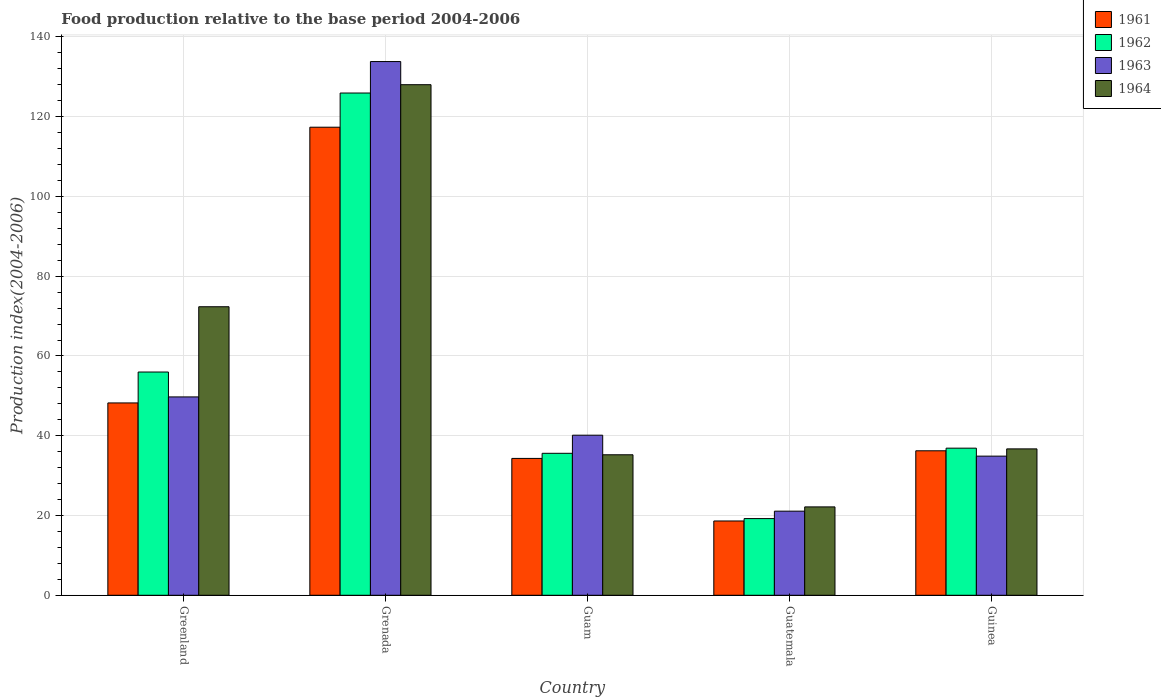How many groups of bars are there?
Your answer should be very brief. 5. How many bars are there on the 4th tick from the right?
Give a very brief answer. 4. What is the label of the 1st group of bars from the left?
Your answer should be compact. Greenland. What is the food production index in 1961 in Guam?
Make the answer very short. 34.32. Across all countries, what is the maximum food production index in 1962?
Make the answer very short. 125.94. Across all countries, what is the minimum food production index in 1962?
Offer a very short reply. 19.23. In which country was the food production index in 1963 maximum?
Provide a short and direct response. Grenada. In which country was the food production index in 1962 minimum?
Ensure brevity in your answer.  Guatemala. What is the total food production index in 1963 in the graph?
Give a very brief answer. 279.69. What is the difference between the food production index in 1963 in Greenland and that in Guatemala?
Provide a short and direct response. 28.65. What is the difference between the food production index in 1964 in Guatemala and the food production index in 1963 in Guinea?
Keep it short and to the point. -12.73. What is the average food production index in 1963 per country?
Offer a very short reply. 55.94. What is the difference between the food production index of/in 1961 and food production index of/in 1962 in Grenada?
Provide a succinct answer. -8.57. What is the ratio of the food production index in 1961 in Grenada to that in Guam?
Your answer should be compact. 3.42. Is the difference between the food production index in 1961 in Greenland and Guatemala greater than the difference between the food production index in 1962 in Greenland and Guatemala?
Offer a very short reply. No. What is the difference between the highest and the second highest food production index in 1963?
Your answer should be very brief. -9.6. What is the difference between the highest and the lowest food production index in 1962?
Ensure brevity in your answer.  106.71. In how many countries, is the food production index in 1961 greater than the average food production index in 1961 taken over all countries?
Ensure brevity in your answer.  1. Is the sum of the food production index in 1961 in Greenland and Grenada greater than the maximum food production index in 1964 across all countries?
Give a very brief answer. Yes. What does the 2nd bar from the left in Guinea represents?
Provide a succinct answer. 1962. What does the 4th bar from the right in Guam represents?
Your answer should be very brief. 1961. Is it the case that in every country, the sum of the food production index in 1961 and food production index in 1964 is greater than the food production index in 1962?
Your response must be concise. Yes. How many bars are there?
Your answer should be very brief. 20. How many countries are there in the graph?
Offer a very short reply. 5. Are the values on the major ticks of Y-axis written in scientific E-notation?
Offer a terse response. No. What is the title of the graph?
Give a very brief answer. Food production relative to the base period 2004-2006. What is the label or title of the X-axis?
Ensure brevity in your answer.  Country. What is the label or title of the Y-axis?
Your answer should be very brief. Production index(2004-2006). What is the Production index(2004-2006) in 1961 in Greenland?
Make the answer very short. 48.23. What is the Production index(2004-2006) in 1962 in Greenland?
Offer a very short reply. 55.98. What is the Production index(2004-2006) in 1963 in Greenland?
Your answer should be compact. 49.74. What is the Production index(2004-2006) in 1964 in Greenland?
Offer a terse response. 72.35. What is the Production index(2004-2006) in 1961 in Grenada?
Keep it short and to the point. 117.37. What is the Production index(2004-2006) in 1962 in Grenada?
Provide a succinct answer. 125.94. What is the Production index(2004-2006) in 1963 in Grenada?
Make the answer very short. 133.83. What is the Production index(2004-2006) of 1964 in Grenada?
Your answer should be compact. 128.03. What is the Production index(2004-2006) in 1961 in Guam?
Offer a very short reply. 34.32. What is the Production index(2004-2006) of 1962 in Guam?
Your answer should be very brief. 35.6. What is the Production index(2004-2006) in 1963 in Guam?
Make the answer very short. 40.14. What is the Production index(2004-2006) in 1964 in Guam?
Provide a succinct answer. 35.23. What is the Production index(2004-2006) in 1961 in Guatemala?
Provide a short and direct response. 18.63. What is the Production index(2004-2006) of 1962 in Guatemala?
Offer a terse response. 19.23. What is the Production index(2004-2006) in 1963 in Guatemala?
Give a very brief answer. 21.09. What is the Production index(2004-2006) of 1964 in Guatemala?
Your answer should be compact. 22.16. What is the Production index(2004-2006) of 1961 in Guinea?
Offer a very short reply. 36.23. What is the Production index(2004-2006) in 1962 in Guinea?
Give a very brief answer. 36.89. What is the Production index(2004-2006) of 1963 in Guinea?
Your answer should be very brief. 34.89. What is the Production index(2004-2006) of 1964 in Guinea?
Give a very brief answer. 36.71. Across all countries, what is the maximum Production index(2004-2006) of 1961?
Keep it short and to the point. 117.37. Across all countries, what is the maximum Production index(2004-2006) in 1962?
Keep it short and to the point. 125.94. Across all countries, what is the maximum Production index(2004-2006) in 1963?
Make the answer very short. 133.83. Across all countries, what is the maximum Production index(2004-2006) in 1964?
Ensure brevity in your answer.  128.03. Across all countries, what is the minimum Production index(2004-2006) in 1961?
Offer a very short reply. 18.63. Across all countries, what is the minimum Production index(2004-2006) in 1962?
Keep it short and to the point. 19.23. Across all countries, what is the minimum Production index(2004-2006) of 1963?
Provide a short and direct response. 21.09. Across all countries, what is the minimum Production index(2004-2006) of 1964?
Your response must be concise. 22.16. What is the total Production index(2004-2006) of 1961 in the graph?
Provide a short and direct response. 254.78. What is the total Production index(2004-2006) in 1962 in the graph?
Your answer should be very brief. 273.64. What is the total Production index(2004-2006) in 1963 in the graph?
Provide a short and direct response. 279.69. What is the total Production index(2004-2006) of 1964 in the graph?
Your answer should be very brief. 294.48. What is the difference between the Production index(2004-2006) of 1961 in Greenland and that in Grenada?
Give a very brief answer. -69.14. What is the difference between the Production index(2004-2006) of 1962 in Greenland and that in Grenada?
Provide a short and direct response. -69.96. What is the difference between the Production index(2004-2006) of 1963 in Greenland and that in Grenada?
Provide a short and direct response. -84.09. What is the difference between the Production index(2004-2006) of 1964 in Greenland and that in Grenada?
Your response must be concise. -55.68. What is the difference between the Production index(2004-2006) in 1961 in Greenland and that in Guam?
Offer a very short reply. 13.91. What is the difference between the Production index(2004-2006) in 1962 in Greenland and that in Guam?
Offer a terse response. 20.38. What is the difference between the Production index(2004-2006) of 1963 in Greenland and that in Guam?
Make the answer very short. 9.6. What is the difference between the Production index(2004-2006) in 1964 in Greenland and that in Guam?
Your answer should be compact. 37.12. What is the difference between the Production index(2004-2006) in 1961 in Greenland and that in Guatemala?
Make the answer very short. 29.6. What is the difference between the Production index(2004-2006) in 1962 in Greenland and that in Guatemala?
Provide a short and direct response. 36.75. What is the difference between the Production index(2004-2006) in 1963 in Greenland and that in Guatemala?
Provide a short and direct response. 28.65. What is the difference between the Production index(2004-2006) in 1964 in Greenland and that in Guatemala?
Offer a very short reply. 50.19. What is the difference between the Production index(2004-2006) in 1961 in Greenland and that in Guinea?
Offer a terse response. 12. What is the difference between the Production index(2004-2006) in 1962 in Greenland and that in Guinea?
Provide a succinct answer. 19.09. What is the difference between the Production index(2004-2006) in 1963 in Greenland and that in Guinea?
Provide a short and direct response. 14.85. What is the difference between the Production index(2004-2006) of 1964 in Greenland and that in Guinea?
Keep it short and to the point. 35.64. What is the difference between the Production index(2004-2006) of 1961 in Grenada and that in Guam?
Your answer should be compact. 83.05. What is the difference between the Production index(2004-2006) of 1962 in Grenada and that in Guam?
Offer a terse response. 90.34. What is the difference between the Production index(2004-2006) of 1963 in Grenada and that in Guam?
Your answer should be very brief. 93.69. What is the difference between the Production index(2004-2006) in 1964 in Grenada and that in Guam?
Make the answer very short. 92.8. What is the difference between the Production index(2004-2006) in 1961 in Grenada and that in Guatemala?
Offer a terse response. 98.74. What is the difference between the Production index(2004-2006) of 1962 in Grenada and that in Guatemala?
Keep it short and to the point. 106.71. What is the difference between the Production index(2004-2006) in 1963 in Grenada and that in Guatemala?
Offer a terse response. 112.74. What is the difference between the Production index(2004-2006) in 1964 in Grenada and that in Guatemala?
Offer a terse response. 105.87. What is the difference between the Production index(2004-2006) of 1961 in Grenada and that in Guinea?
Offer a terse response. 81.14. What is the difference between the Production index(2004-2006) of 1962 in Grenada and that in Guinea?
Your answer should be very brief. 89.05. What is the difference between the Production index(2004-2006) of 1963 in Grenada and that in Guinea?
Offer a very short reply. 98.94. What is the difference between the Production index(2004-2006) of 1964 in Grenada and that in Guinea?
Your answer should be compact. 91.32. What is the difference between the Production index(2004-2006) of 1961 in Guam and that in Guatemala?
Offer a very short reply. 15.69. What is the difference between the Production index(2004-2006) in 1962 in Guam and that in Guatemala?
Provide a short and direct response. 16.37. What is the difference between the Production index(2004-2006) in 1963 in Guam and that in Guatemala?
Your answer should be compact. 19.05. What is the difference between the Production index(2004-2006) of 1964 in Guam and that in Guatemala?
Your answer should be compact. 13.07. What is the difference between the Production index(2004-2006) in 1961 in Guam and that in Guinea?
Your answer should be compact. -1.91. What is the difference between the Production index(2004-2006) in 1962 in Guam and that in Guinea?
Give a very brief answer. -1.29. What is the difference between the Production index(2004-2006) of 1963 in Guam and that in Guinea?
Your answer should be compact. 5.25. What is the difference between the Production index(2004-2006) of 1964 in Guam and that in Guinea?
Make the answer very short. -1.48. What is the difference between the Production index(2004-2006) of 1961 in Guatemala and that in Guinea?
Offer a terse response. -17.6. What is the difference between the Production index(2004-2006) of 1962 in Guatemala and that in Guinea?
Offer a very short reply. -17.66. What is the difference between the Production index(2004-2006) of 1964 in Guatemala and that in Guinea?
Provide a succinct answer. -14.55. What is the difference between the Production index(2004-2006) of 1961 in Greenland and the Production index(2004-2006) of 1962 in Grenada?
Give a very brief answer. -77.71. What is the difference between the Production index(2004-2006) of 1961 in Greenland and the Production index(2004-2006) of 1963 in Grenada?
Ensure brevity in your answer.  -85.6. What is the difference between the Production index(2004-2006) of 1961 in Greenland and the Production index(2004-2006) of 1964 in Grenada?
Your response must be concise. -79.8. What is the difference between the Production index(2004-2006) in 1962 in Greenland and the Production index(2004-2006) in 1963 in Grenada?
Offer a terse response. -77.85. What is the difference between the Production index(2004-2006) in 1962 in Greenland and the Production index(2004-2006) in 1964 in Grenada?
Keep it short and to the point. -72.05. What is the difference between the Production index(2004-2006) of 1963 in Greenland and the Production index(2004-2006) of 1964 in Grenada?
Give a very brief answer. -78.29. What is the difference between the Production index(2004-2006) of 1961 in Greenland and the Production index(2004-2006) of 1962 in Guam?
Offer a terse response. 12.63. What is the difference between the Production index(2004-2006) in 1961 in Greenland and the Production index(2004-2006) in 1963 in Guam?
Offer a terse response. 8.09. What is the difference between the Production index(2004-2006) of 1961 in Greenland and the Production index(2004-2006) of 1964 in Guam?
Your answer should be very brief. 13. What is the difference between the Production index(2004-2006) in 1962 in Greenland and the Production index(2004-2006) in 1963 in Guam?
Offer a very short reply. 15.84. What is the difference between the Production index(2004-2006) in 1962 in Greenland and the Production index(2004-2006) in 1964 in Guam?
Your answer should be compact. 20.75. What is the difference between the Production index(2004-2006) in 1963 in Greenland and the Production index(2004-2006) in 1964 in Guam?
Offer a very short reply. 14.51. What is the difference between the Production index(2004-2006) of 1961 in Greenland and the Production index(2004-2006) of 1963 in Guatemala?
Keep it short and to the point. 27.14. What is the difference between the Production index(2004-2006) of 1961 in Greenland and the Production index(2004-2006) of 1964 in Guatemala?
Ensure brevity in your answer.  26.07. What is the difference between the Production index(2004-2006) of 1962 in Greenland and the Production index(2004-2006) of 1963 in Guatemala?
Offer a very short reply. 34.89. What is the difference between the Production index(2004-2006) of 1962 in Greenland and the Production index(2004-2006) of 1964 in Guatemala?
Your answer should be very brief. 33.82. What is the difference between the Production index(2004-2006) of 1963 in Greenland and the Production index(2004-2006) of 1964 in Guatemala?
Ensure brevity in your answer.  27.58. What is the difference between the Production index(2004-2006) of 1961 in Greenland and the Production index(2004-2006) of 1962 in Guinea?
Give a very brief answer. 11.34. What is the difference between the Production index(2004-2006) of 1961 in Greenland and the Production index(2004-2006) of 1963 in Guinea?
Ensure brevity in your answer.  13.34. What is the difference between the Production index(2004-2006) of 1961 in Greenland and the Production index(2004-2006) of 1964 in Guinea?
Offer a terse response. 11.52. What is the difference between the Production index(2004-2006) of 1962 in Greenland and the Production index(2004-2006) of 1963 in Guinea?
Keep it short and to the point. 21.09. What is the difference between the Production index(2004-2006) in 1962 in Greenland and the Production index(2004-2006) in 1964 in Guinea?
Keep it short and to the point. 19.27. What is the difference between the Production index(2004-2006) in 1963 in Greenland and the Production index(2004-2006) in 1964 in Guinea?
Offer a very short reply. 13.03. What is the difference between the Production index(2004-2006) in 1961 in Grenada and the Production index(2004-2006) in 1962 in Guam?
Your answer should be compact. 81.77. What is the difference between the Production index(2004-2006) of 1961 in Grenada and the Production index(2004-2006) of 1963 in Guam?
Keep it short and to the point. 77.23. What is the difference between the Production index(2004-2006) of 1961 in Grenada and the Production index(2004-2006) of 1964 in Guam?
Provide a succinct answer. 82.14. What is the difference between the Production index(2004-2006) in 1962 in Grenada and the Production index(2004-2006) in 1963 in Guam?
Keep it short and to the point. 85.8. What is the difference between the Production index(2004-2006) of 1962 in Grenada and the Production index(2004-2006) of 1964 in Guam?
Provide a succinct answer. 90.71. What is the difference between the Production index(2004-2006) in 1963 in Grenada and the Production index(2004-2006) in 1964 in Guam?
Your response must be concise. 98.6. What is the difference between the Production index(2004-2006) in 1961 in Grenada and the Production index(2004-2006) in 1962 in Guatemala?
Make the answer very short. 98.14. What is the difference between the Production index(2004-2006) of 1961 in Grenada and the Production index(2004-2006) of 1963 in Guatemala?
Offer a terse response. 96.28. What is the difference between the Production index(2004-2006) in 1961 in Grenada and the Production index(2004-2006) in 1964 in Guatemala?
Give a very brief answer. 95.21. What is the difference between the Production index(2004-2006) of 1962 in Grenada and the Production index(2004-2006) of 1963 in Guatemala?
Provide a short and direct response. 104.85. What is the difference between the Production index(2004-2006) in 1962 in Grenada and the Production index(2004-2006) in 1964 in Guatemala?
Ensure brevity in your answer.  103.78. What is the difference between the Production index(2004-2006) in 1963 in Grenada and the Production index(2004-2006) in 1964 in Guatemala?
Keep it short and to the point. 111.67. What is the difference between the Production index(2004-2006) of 1961 in Grenada and the Production index(2004-2006) of 1962 in Guinea?
Provide a short and direct response. 80.48. What is the difference between the Production index(2004-2006) in 1961 in Grenada and the Production index(2004-2006) in 1963 in Guinea?
Offer a very short reply. 82.48. What is the difference between the Production index(2004-2006) in 1961 in Grenada and the Production index(2004-2006) in 1964 in Guinea?
Make the answer very short. 80.66. What is the difference between the Production index(2004-2006) of 1962 in Grenada and the Production index(2004-2006) of 1963 in Guinea?
Give a very brief answer. 91.05. What is the difference between the Production index(2004-2006) in 1962 in Grenada and the Production index(2004-2006) in 1964 in Guinea?
Your response must be concise. 89.23. What is the difference between the Production index(2004-2006) of 1963 in Grenada and the Production index(2004-2006) of 1964 in Guinea?
Your response must be concise. 97.12. What is the difference between the Production index(2004-2006) in 1961 in Guam and the Production index(2004-2006) in 1962 in Guatemala?
Provide a succinct answer. 15.09. What is the difference between the Production index(2004-2006) in 1961 in Guam and the Production index(2004-2006) in 1963 in Guatemala?
Keep it short and to the point. 13.23. What is the difference between the Production index(2004-2006) of 1961 in Guam and the Production index(2004-2006) of 1964 in Guatemala?
Provide a short and direct response. 12.16. What is the difference between the Production index(2004-2006) of 1962 in Guam and the Production index(2004-2006) of 1963 in Guatemala?
Offer a very short reply. 14.51. What is the difference between the Production index(2004-2006) in 1962 in Guam and the Production index(2004-2006) in 1964 in Guatemala?
Keep it short and to the point. 13.44. What is the difference between the Production index(2004-2006) in 1963 in Guam and the Production index(2004-2006) in 1964 in Guatemala?
Offer a terse response. 17.98. What is the difference between the Production index(2004-2006) of 1961 in Guam and the Production index(2004-2006) of 1962 in Guinea?
Provide a short and direct response. -2.57. What is the difference between the Production index(2004-2006) in 1961 in Guam and the Production index(2004-2006) in 1963 in Guinea?
Your response must be concise. -0.57. What is the difference between the Production index(2004-2006) of 1961 in Guam and the Production index(2004-2006) of 1964 in Guinea?
Offer a terse response. -2.39. What is the difference between the Production index(2004-2006) of 1962 in Guam and the Production index(2004-2006) of 1963 in Guinea?
Make the answer very short. 0.71. What is the difference between the Production index(2004-2006) in 1962 in Guam and the Production index(2004-2006) in 1964 in Guinea?
Keep it short and to the point. -1.11. What is the difference between the Production index(2004-2006) of 1963 in Guam and the Production index(2004-2006) of 1964 in Guinea?
Give a very brief answer. 3.43. What is the difference between the Production index(2004-2006) in 1961 in Guatemala and the Production index(2004-2006) in 1962 in Guinea?
Ensure brevity in your answer.  -18.26. What is the difference between the Production index(2004-2006) of 1961 in Guatemala and the Production index(2004-2006) of 1963 in Guinea?
Provide a short and direct response. -16.26. What is the difference between the Production index(2004-2006) of 1961 in Guatemala and the Production index(2004-2006) of 1964 in Guinea?
Provide a short and direct response. -18.08. What is the difference between the Production index(2004-2006) of 1962 in Guatemala and the Production index(2004-2006) of 1963 in Guinea?
Make the answer very short. -15.66. What is the difference between the Production index(2004-2006) of 1962 in Guatemala and the Production index(2004-2006) of 1964 in Guinea?
Keep it short and to the point. -17.48. What is the difference between the Production index(2004-2006) of 1963 in Guatemala and the Production index(2004-2006) of 1964 in Guinea?
Provide a succinct answer. -15.62. What is the average Production index(2004-2006) of 1961 per country?
Ensure brevity in your answer.  50.96. What is the average Production index(2004-2006) in 1962 per country?
Your answer should be compact. 54.73. What is the average Production index(2004-2006) in 1963 per country?
Your response must be concise. 55.94. What is the average Production index(2004-2006) of 1964 per country?
Make the answer very short. 58.9. What is the difference between the Production index(2004-2006) of 1961 and Production index(2004-2006) of 1962 in Greenland?
Your answer should be compact. -7.75. What is the difference between the Production index(2004-2006) of 1961 and Production index(2004-2006) of 1963 in Greenland?
Provide a short and direct response. -1.51. What is the difference between the Production index(2004-2006) of 1961 and Production index(2004-2006) of 1964 in Greenland?
Your answer should be compact. -24.12. What is the difference between the Production index(2004-2006) of 1962 and Production index(2004-2006) of 1963 in Greenland?
Give a very brief answer. 6.24. What is the difference between the Production index(2004-2006) of 1962 and Production index(2004-2006) of 1964 in Greenland?
Ensure brevity in your answer.  -16.37. What is the difference between the Production index(2004-2006) of 1963 and Production index(2004-2006) of 1964 in Greenland?
Offer a very short reply. -22.61. What is the difference between the Production index(2004-2006) of 1961 and Production index(2004-2006) of 1962 in Grenada?
Provide a succinct answer. -8.57. What is the difference between the Production index(2004-2006) in 1961 and Production index(2004-2006) in 1963 in Grenada?
Make the answer very short. -16.46. What is the difference between the Production index(2004-2006) in 1961 and Production index(2004-2006) in 1964 in Grenada?
Provide a succinct answer. -10.66. What is the difference between the Production index(2004-2006) in 1962 and Production index(2004-2006) in 1963 in Grenada?
Your answer should be compact. -7.89. What is the difference between the Production index(2004-2006) of 1962 and Production index(2004-2006) of 1964 in Grenada?
Keep it short and to the point. -2.09. What is the difference between the Production index(2004-2006) of 1961 and Production index(2004-2006) of 1962 in Guam?
Your answer should be compact. -1.28. What is the difference between the Production index(2004-2006) in 1961 and Production index(2004-2006) in 1963 in Guam?
Offer a terse response. -5.82. What is the difference between the Production index(2004-2006) of 1961 and Production index(2004-2006) of 1964 in Guam?
Your answer should be compact. -0.91. What is the difference between the Production index(2004-2006) in 1962 and Production index(2004-2006) in 1963 in Guam?
Offer a terse response. -4.54. What is the difference between the Production index(2004-2006) in 1962 and Production index(2004-2006) in 1964 in Guam?
Offer a very short reply. 0.37. What is the difference between the Production index(2004-2006) of 1963 and Production index(2004-2006) of 1964 in Guam?
Your answer should be compact. 4.91. What is the difference between the Production index(2004-2006) of 1961 and Production index(2004-2006) of 1962 in Guatemala?
Keep it short and to the point. -0.6. What is the difference between the Production index(2004-2006) in 1961 and Production index(2004-2006) in 1963 in Guatemala?
Provide a short and direct response. -2.46. What is the difference between the Production index(2004-2006) in 1961 and Production index(2004-2006) in 1964 in Guatemala?
Give a very brief answer. -3.53. What is the difference between the Production index(2004-2006) in 1962 and Production index(2004-2006) in 1963 in Guatemala?
Provide a short and direct response. -1.86. What is the difference between the Production index(2004-2006) in 1962 and Production index(2004-2006) in 1964 in Guatemala?
Provide a short and direct response. -2.93. What is the difference between the Production index(2004-2006) in 1963 and Production index(2004-2006) in 1964 in Guatemala?
Provide a short and direct response. -1.07. What is the difference between the Production index(2004-2006) in 1961 and Production index(2004-2006) in 1962 in Guinea?
Offer a terse response. -0.66. What is the difference between the Production index(2004-2006) in 1961 and Production index(2004-2006) in 1963 in Guinea?
Provide a succinct answer. 1.34. What is the difference between the Production index(2004-2006) of 1961 and Production index(2004-2006) of 1964 in Guinea?
Offer a terse response. -0.48. What is the difference between the Production index(2004-2006) in 1962 and Production index(2004-2006) in 1963 in Guinea?
Keep it short and to the point. 2. What is the difference between the Production index(2004-2006) of 1962 and Production index(2004-2006) of 1964 in Guinea?
Your answer should be compact. 0.18. What is the difference between the Production index(2004-2006) in 1963 and Production index(2004-2006) in 1964 in Guinea?
Provide a short and direct response. -1.82. What is the ratio of the Production index(2004-2006) in 1961 in Greenland to that in Grenada?
Provide a succinct answer. 0.41. What is the ratio of the Production index(2004-2006) in 1962 in Greenland to that in Grenada?
Ensure brevity in your answer.  0.44. What is the ratio of the Production index(2004-2006) in 1963 in Greenland to that in Grenada?
Keep it short and to the point. 0.37. What is the ratio of the Production index(2004-2006) of 1964 in Greenland to that in Grenada?
Give a very brief answer. 0.57. What is the ratio of the Production index(2004-2006) in 1961 in Greenland to that in Guam?
Offer a terse response. 1.41. What is the ratio of the Production index(2004-2006) of 1962 in Greenland to that in Guam?
Your answer should be very brief. 1.57. What is the ratio of the Production index(2004-2006) of 1963 in Greenland to that in Guam?
Provide a succinct answer. 1.24. What is the ratio of the Production index(2004-2006) of 1964 in Greenland to that in Guam?
Your answer should be very brief. 2.05. What is the ratio of the Production index(2004-2006) in 1961 in Greenland to that in Guatemala?
Provide a short and direct response. 2.59. What is the ratio of the Production index(2004-2006) in 1962 in Greenland to that in Guatemala?
Provide a short and direct response. 2.91. What is the ratio of the Production index(2004-2006) in 1963 in Greenland to that in Guatemala?
Keep it short and to the point. 2.36. What is the ratio of the Production index(2004-2006) of 1964 in Greenland to that in Guatemala?
Give a very brief answer. 3.26. What is the ratio of the Production index(2004-2006) of 1961 in Greenland to that in Guinea?
Your response must be concise. 1.33. What is the ratio of the Production index(2004-2006) of 1962 in Greenland to that in Guinea?
Your response must be concise. 1.52. What is the ratio of the Production index(2004-2006) of 1963 in Greenland to that in Guinea?
Give a very brief answer. 1.43. What is the ratio of the Production index(2004-2006) of 1964 in Greenland to that in Guinea?
Give a very brief answer. 1.97. What is the ratio of the Production index(2004-2006) of 1961 in Grenada to that in Guam?
Provide a short and direct response. 3.42. What is the ratio of the Production index(2004-2006) in 1962 in Grenada to that in Guam?
Ensure brevity in your answer.  3.54. What is the ratio of the Production index(2004-2006) of 1963 in Grenada to that in Guam?
Give a very brief answer. 3.33. What is the ratio of the Production index(2004-2006) in 1964 in Grenada to that in Guam?
Make the answer very short. 3.63. What is the ratio of the Production index(2004-2006) of 1961 in Grenada to that in Guatemala?
Keep it short and to the point. 6.3. What is the ratio of the Production index(2004-2006) in 1962 in Grenada to that in Guatemala?
Provide a short and direct response. 6.55. What is the ratio of the Production index(2004-2006) of 1963 in Grenada to that in Guatemala?
Your answer should be very brief. 6.35. What is the ratio of the Production index(2004-2006) in 1964 in Grenada to that in Guatemala?
Ensure brevity in your answer.  5.78. What is the ratio of the Production index(2004-2006) in 1961 in Grenada to that in Guinea?
Offer a terse response. 3.24. What is the ratio of the Production index(2004-2006) in 1962 in Grenada to that in Guinea?
Ensure brevity in your answer.  3.41. What is the ratio of the Production index(2004-2006) in 1963 in Grenada to that in Guinea?
Your answer should be very brief. 3.84. What is the ratio of the Production index(2004-2006) in 1964 in Grenada to that in Guinea?
Offer a very short reply. 3.49. What is the ratio of the Production index(2004-2006) of 1961 in Guam to that in Guatemala?
Make the answer very short. 1.84. What is the ratio of the Production index(2004-2006) in 1962 in Guam to that in Guatemala?
Ensure brevity in your answer.  1.85. What is the ratio of the Production index(2004-2006) in 1963 in Guam to that in Guatemala?
Your answer should be very brief. 1.9. What is the ratio of the Production index(2004-2006) in 1964 in Guam to that in Guatemala?
Your answer should be very brief. 1.59. What is the ratio of the Production index(2004-2006) in 1961 in Guam to that in Guinea?
Your answer should be very brief. 0.95. What is the ratio of the Production index(2004-2006) in 1962 in Guam to that in Guinea?
Your answer should be compact. 0.96. What is the ratio of the Production index(2004-2006) in 1963 in Guam to that in Guinea?
Your response must be concise. 1.15. What is the ratio of the Production index(2004-2006) in 1964 in Guam to that in Guinea?
Keep it short and to the point. 0.96. What is the ratio of the Production index(2004-2006) in 1961 in Guatemala to that in Guinea?
Your answer should be compact. 0.51. What is the ratio of the Production index(2004-2006) in 1962 in Guatemala to that in Guinea?
Offer a very short reply. 0.52. What is the ratio of the Production index(2004-2006) of 1963 in Guatemala to that in Guinea?
Offer a terse response. 0.6. What is the ratio of the Production index(2004-2006) in 1964 in Guatemala to that in Guinea?
Offer a very short reply. 0.6. What is the difference between the highest and the second highest Production index(2004-2006) in 1961?
Provide a short and direct response. 69.14. What is the difference between the highest and the second highest Production index(2004-2006) of 1962?
Your response must be concise. 69.96. What is the difference between the highest and the second highest Production index(2004-2006) of 1963?
Offer a very short reply. 84.09. What is the difference between the highest and the second highest Production index(2004-2006) of 1964?
Your answer should be very brief. 55.68. What is the difference between the highest and the lowest Production index(2004-2006) of 1961?
Give a very brief answer. 98.74. What is the difference between the highest and the lowest Production index(2004-2006) in 1962?
Provide a short and direct response. 106.71. What is the difference between the highest and the lowest Production index(2004-2006) in 1963?
Offer a terse response. 112.74. What is the difference between the highest and the lowest Production index(2004-2006) in 1964?
Ensure brevity in your answer.  105.87. 